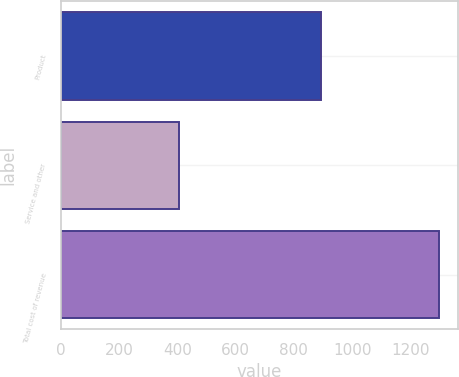Convert chart to OTSL. <chart><loc_0><loc_0><loc_500><loc_500><bar_chart><fcel>Product<fcel>Service and other<fcel>Total cost of revenue<nl><fcel>893<fcel>405<fcel>1298<nl></chart> 